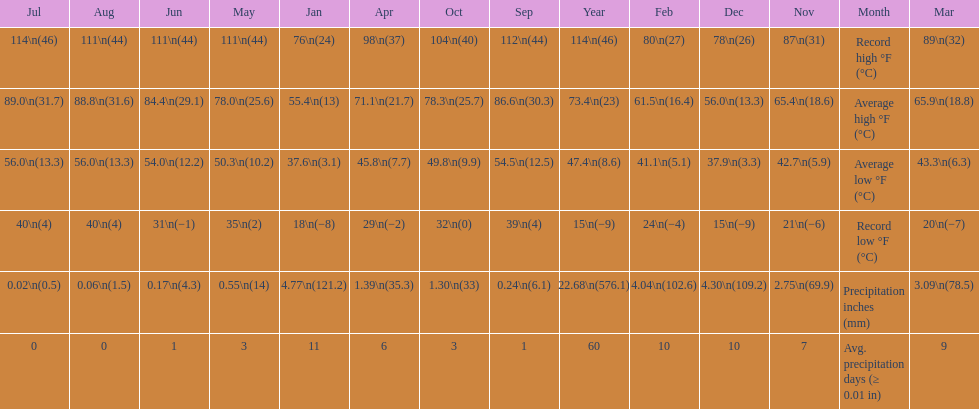Which month had an average high of 89.0 degrees and an average low of 56.0 degrees? July. 